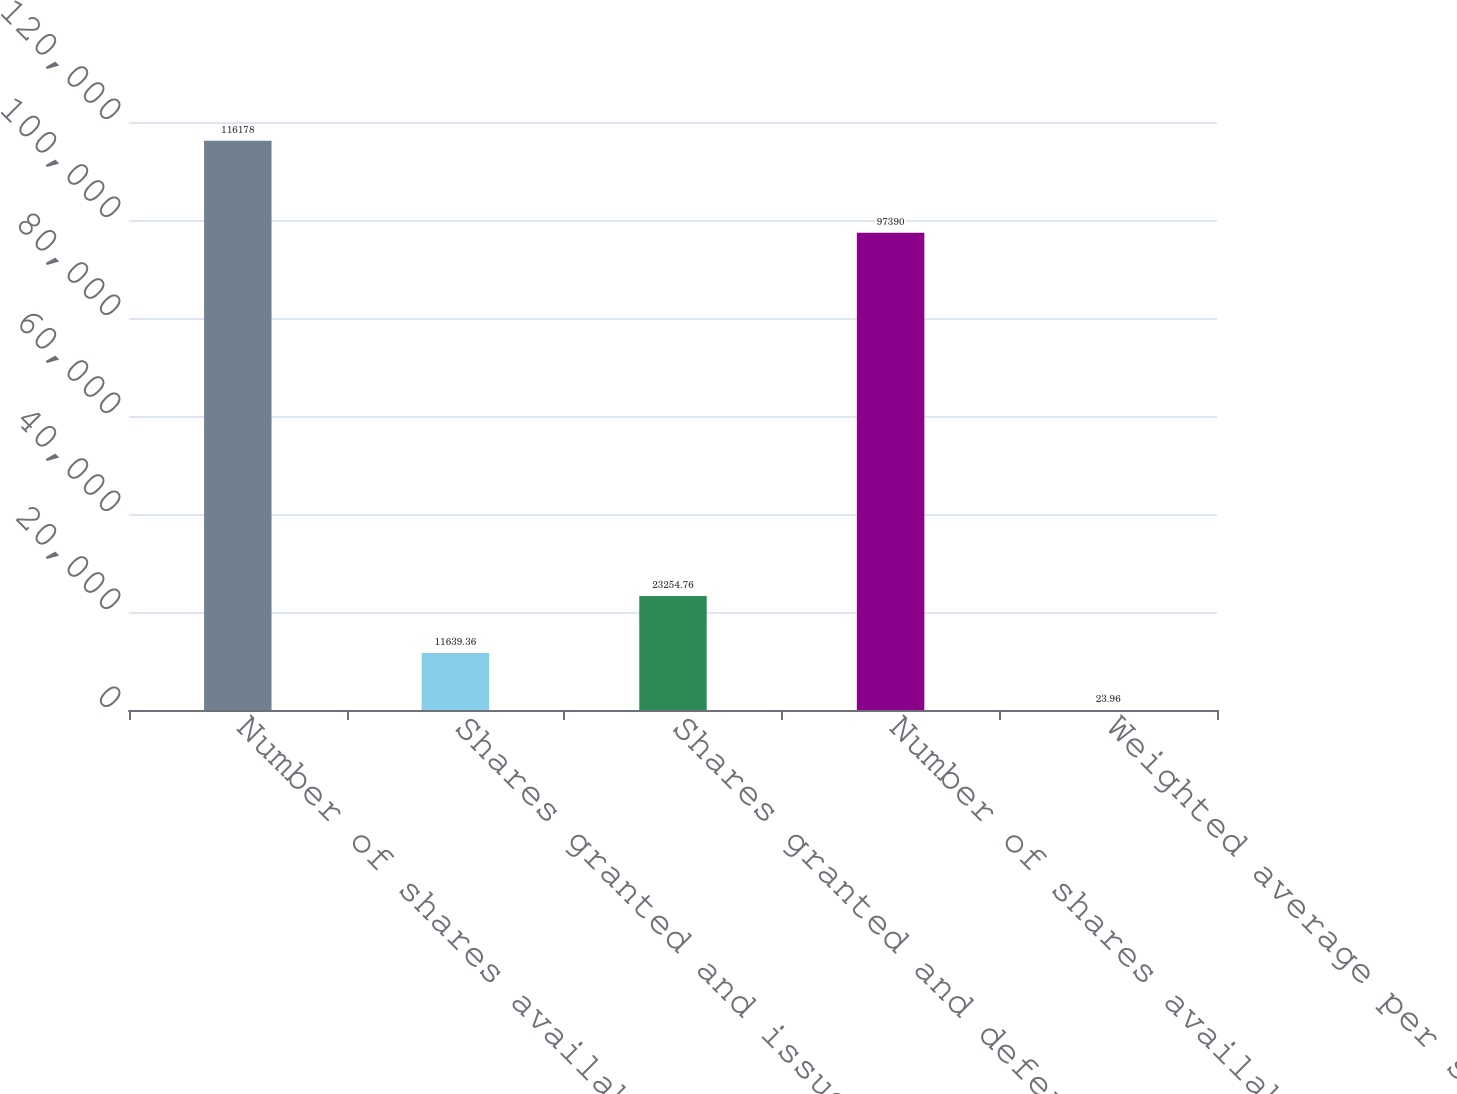Convert chart. <chart><loc_0><loc_0><loc_500><loc_500><bar_chart><fcel>Number of shares available<fcel>Shares granted and issued<fcel>Shares granted and deferred<fcel>Number of shares available end<fcel>Weighted average per share<nl><fcel>116178<fcel>11639.4<fcel>23254.8<fcel>97390<fcel>23.96<nl></chart> 